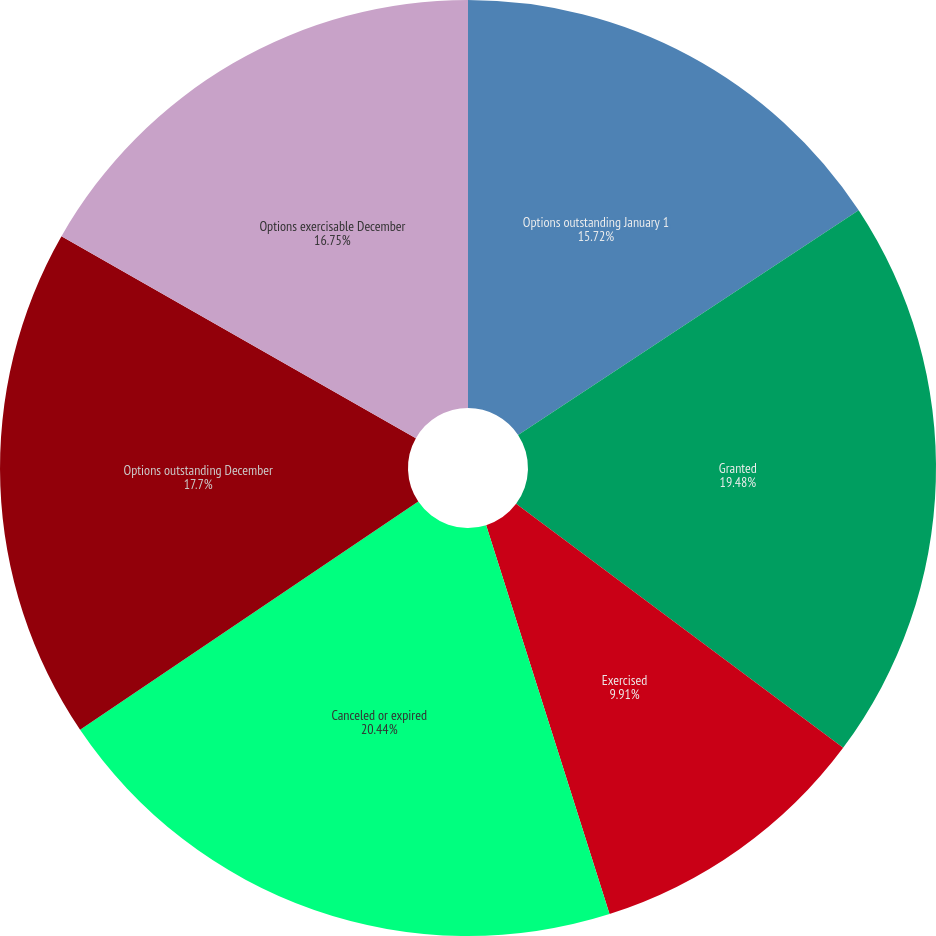Convert chart to OTSL. <chart><loc_0><loc_0><loc_500><loc_500><pie_chart><fcel>Options outstanding January 1<fcel>Granted<fcel>Exercised<fcel>Canceled or expired<fcel>Options outstanding December<fcel>Options exercisable December<nl><fcel>15.72%<fcel>19.48%<fcel>9.91%<fcel>20.44%<fcel>17.7%<fcel>16.75%<nl></chart> 